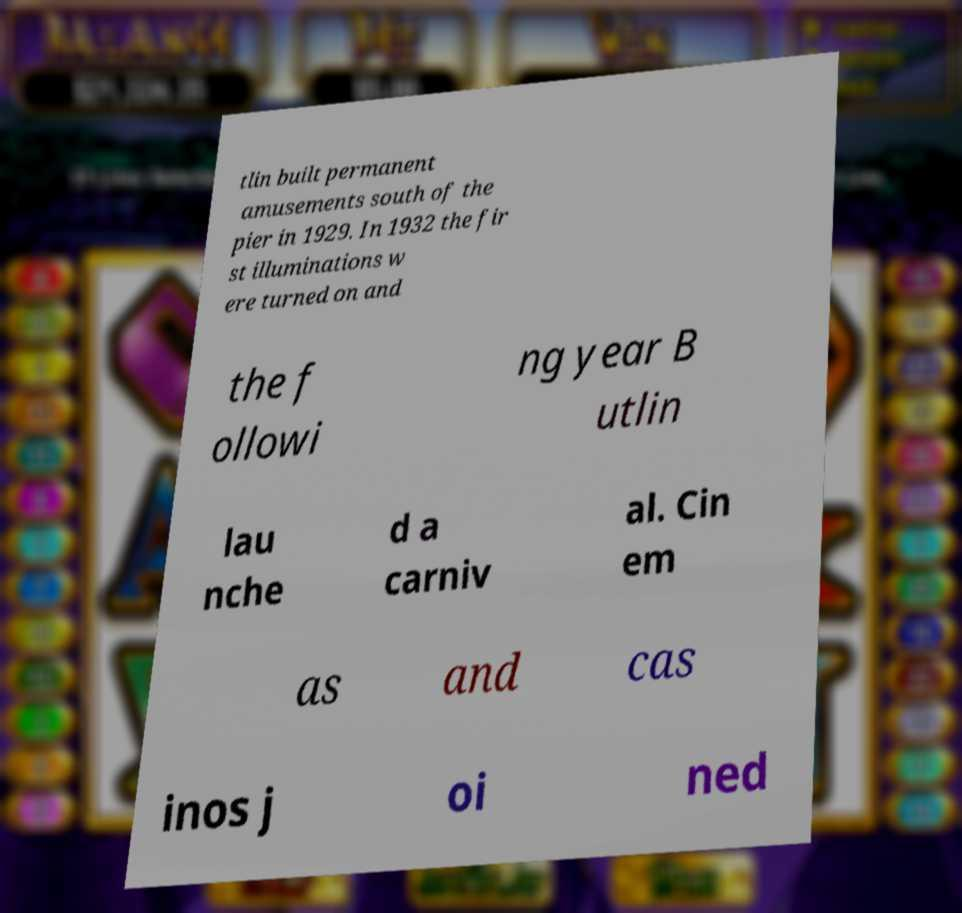There's text embedded in this image that I need extracted. Can you transcribe it verbatim? tlin built permanent amusements south of the pier in 1929. In 1932 the fir st illuminations w ere turned on and the f ollowi ng year B utlin lau nche d a carniv al. Cin em as and cas inos j oi ned 